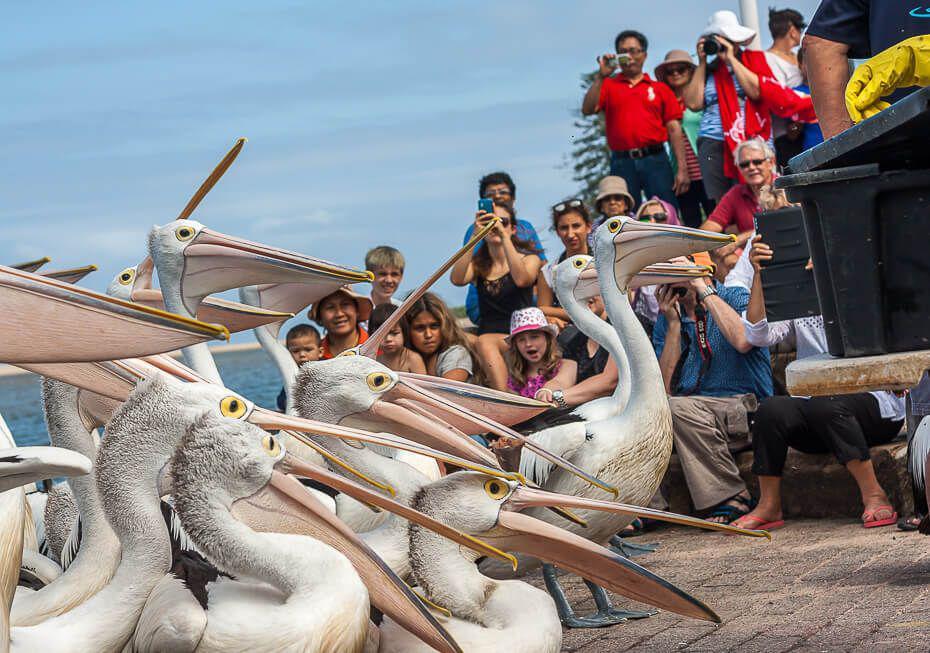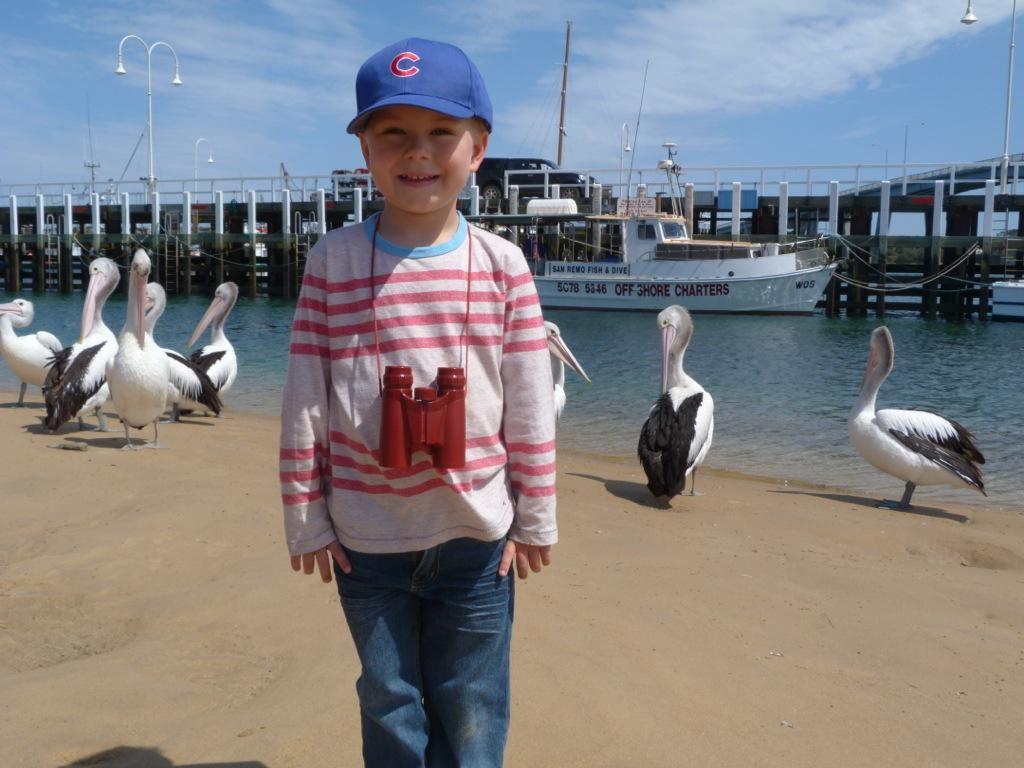The first image is the image on the left, the second image is the image on the right. Analyze the images presented: Is the assertion "A group of spectators are observing the pelicans." valid? Answer yes or no. Yes. The first image is the image on the left, the second image is the image on the right. For the images displayed, is the sentence "There are more than 5 pelicans facing right." factually correct? Answer yes or no. Yes. 